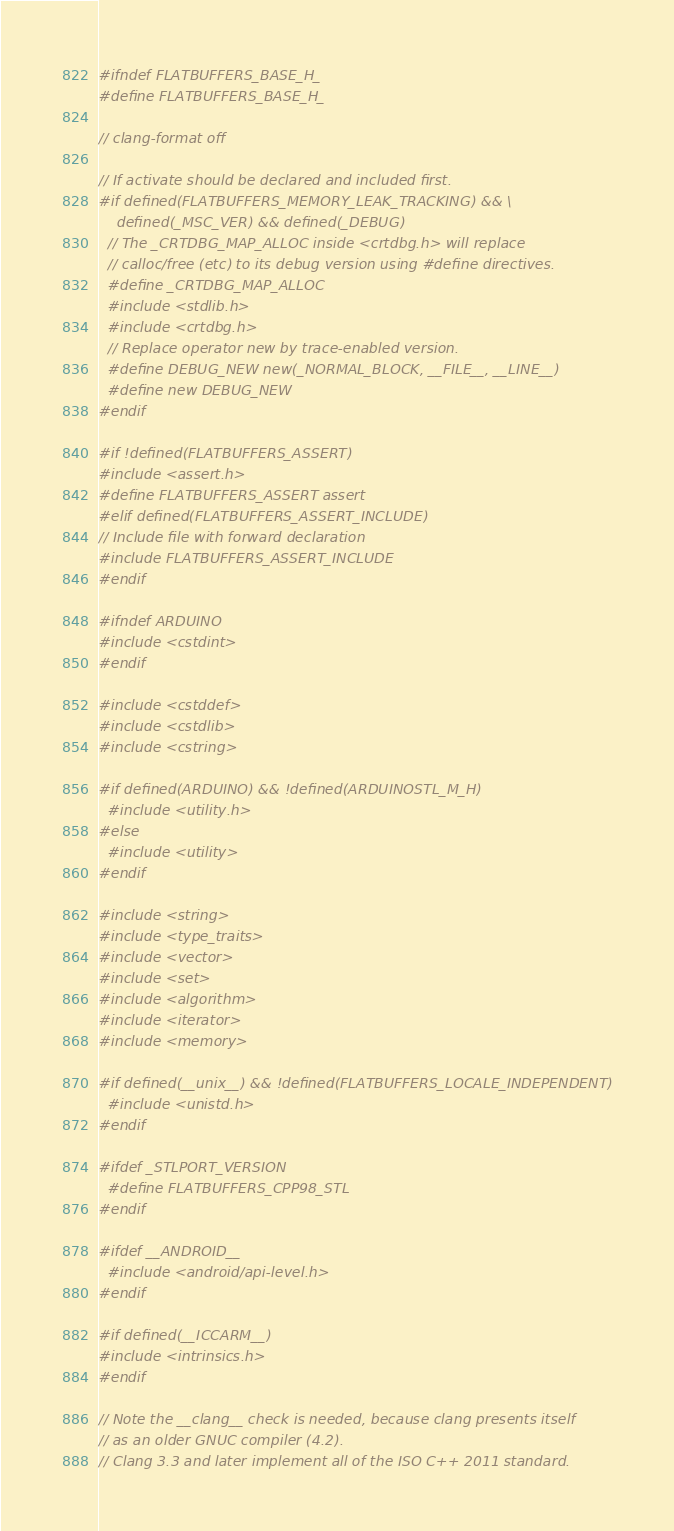<code> <loc_0><loc_0><loc_500><loc_500><_C_>#ifndef FLATBUFFERS_BASE_H_
#define FLATBUFFERS_BASE_H_

// clang-format off

// If activate should be declared and included first.
#if defined(FLATBUFFERS_MEMORY_LEAK_TRACKING) && \
    defined(_MSC_VER) && defined(_DEBUG)
  // The _CRTDBG_MAP_ALLOC inside <crtdbg.h> will replace
  // calloc/free (etc) to its debug version using #define directives.
  #define _CRTDBG_MAP_ALLOC
  #include <stdlib.h>
  #include <crtdbg.h>
  // Replace operator new by trace-enabled version.
  #define DEBUG_NEW new(_NORMAL_BLOCK, __FILE__, __LINE__)
  #define new DEBUG_NEW
#endif

#if !defined(FLATBUFFERS_ASSERT)
#include <assert.h>
#define FLATBUFFERS_ASSERT assert
#elif defined(FLATBUFFERS_ASSERT_INCLUDE)
// Include file with forward declaration
#include FLATBUFFERS_ASSERT_INCLUDE
#endif

#ifndef ARDUINO
#include <cstdint>
#endif

#include <cstddef>
#include <cstdlib>
#include <cstring>

#if defined(ARDUINO) && !defined(ARDUINOSTL_M_H)
  #include <utility.h>
#else
  #include <utility>
#endif

#include <string>
#include <type_traits>
#include <vector>
#include <set>
#include <algorithm>
#include <iterator>
#include <memory>

#if defined(__unix__) && !defined(FLATBUFFERS_LOCALE_INDEPENDENT)
  #include <unistd.h>
#endif

#ifdef _STLPORT_VERSION
  #define FLATBUFFERS_CPP98_STL
#endif

#ifdef __ANDROID__
  #include <android/api-level.h>
#endif

#if defined(__ICCARM__)
#include <intrinsics.h>
#endif

// Note the __clang__ check is needed, because clang presents itself
// as an older GNUC compiler (4.2).
// Clang 3.3 and later implement all of the ISO C++ 2011 standard.</code> 